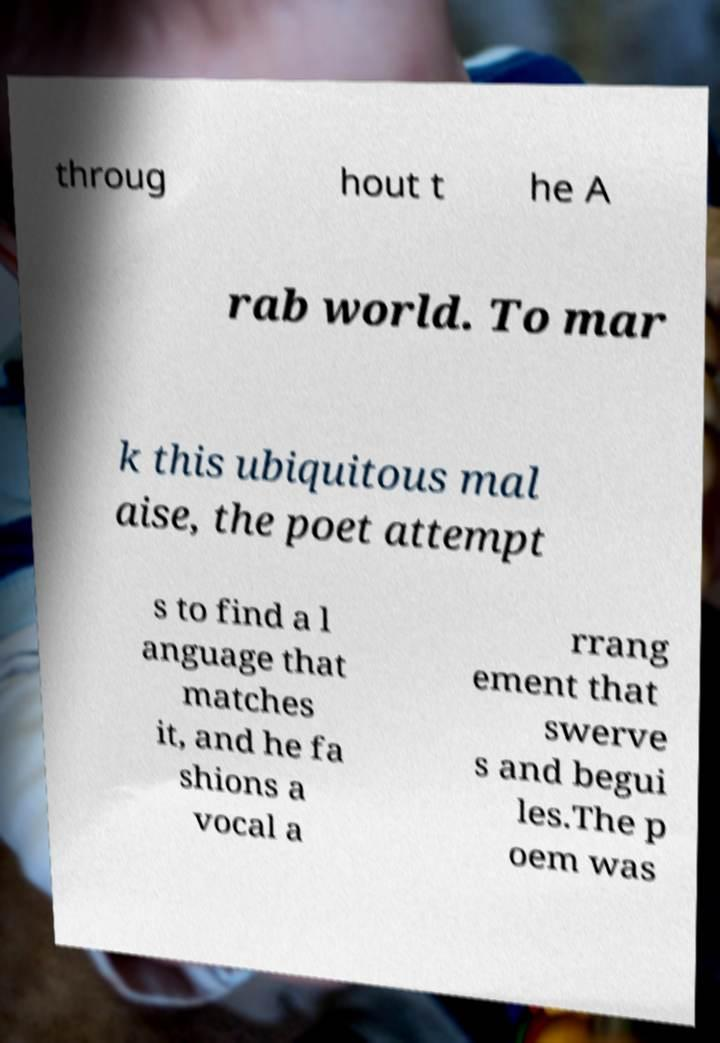I need the written content from this picture converted into text. Can you do that? throug hout t he A rab world. To mar k this ubiquitous mal aise, the poet attempt s to find a l anguage that matches it, and he fa shions a vocal a rrang ement that swerve s and begui les.The p oem was 